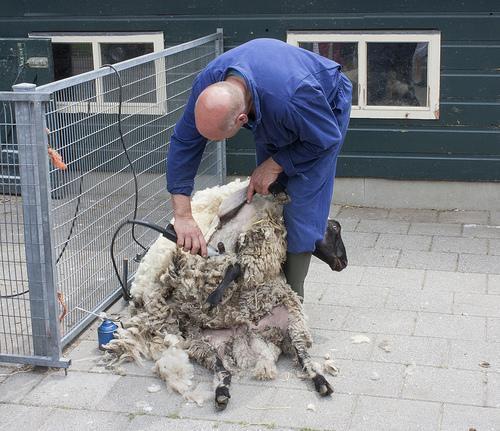How many people are in the picture?
Give a very brief answer. 1. 